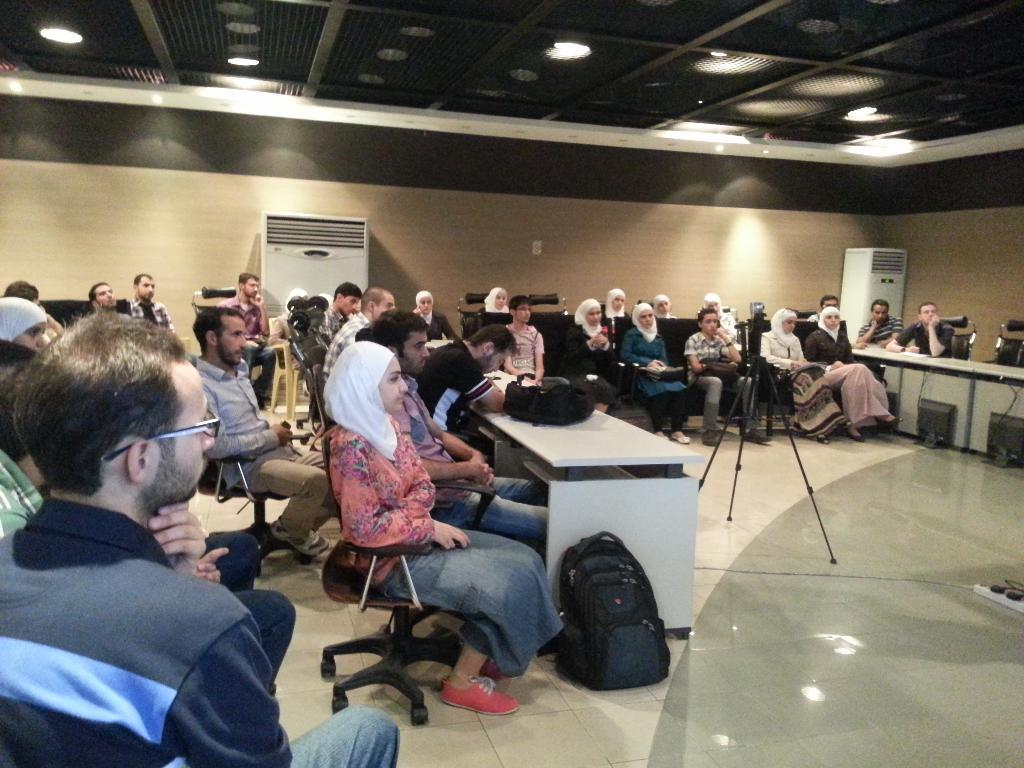What are the people in the image doing? The people in the image are sitting on chairs. What objects can be seen near the people? Bags are visible in the image. What appliances are present in the image? Air conditioners are present in the image. What device is used for recording in the image? A video camera is visible in the image. What can be seen in the background of the image? There is a wall and a ceiling with lights in the background of the image. What type of fairies can be seen flying around the people in the image? There are no fairies present in the image; it only features people sitting on chairs, bags, air conditioners, a video camera, and the background elements. 